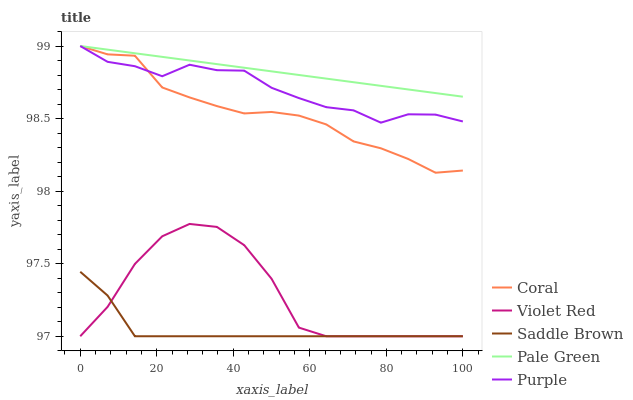Does Saddle Brown have the minimum area under the curve?
Answer yes or no. Yes. Does Pale Green have the maximum area under the curve?
Answer yes or no. Yes. Does Coral have the minimum area under the curve?
Answer yes or no. No. Does Coral have the maximum area under the curve?
Answer yes or no. No. Is Pale Green the smoothest?
Answer yes or no. Yes. Is Violet Red the roughest?
Answer yes or no. Yes. Is Coral the smoothest?
Answer yes or no. No. Is Coral the roughest?
Answer yes or no. No. Does Coral have the lowest value?
Answer yes or no. No. Does Violet Red have the highest value?
Answer yes or no. No. Is Saddle Brown less than Purple?
Answer yes or no. Yes. Is Pale Green greater than Violet Red?
Answer yes or no. Yes. Does Saddle Brown intersect Purple?
Answer yes or no. No. 